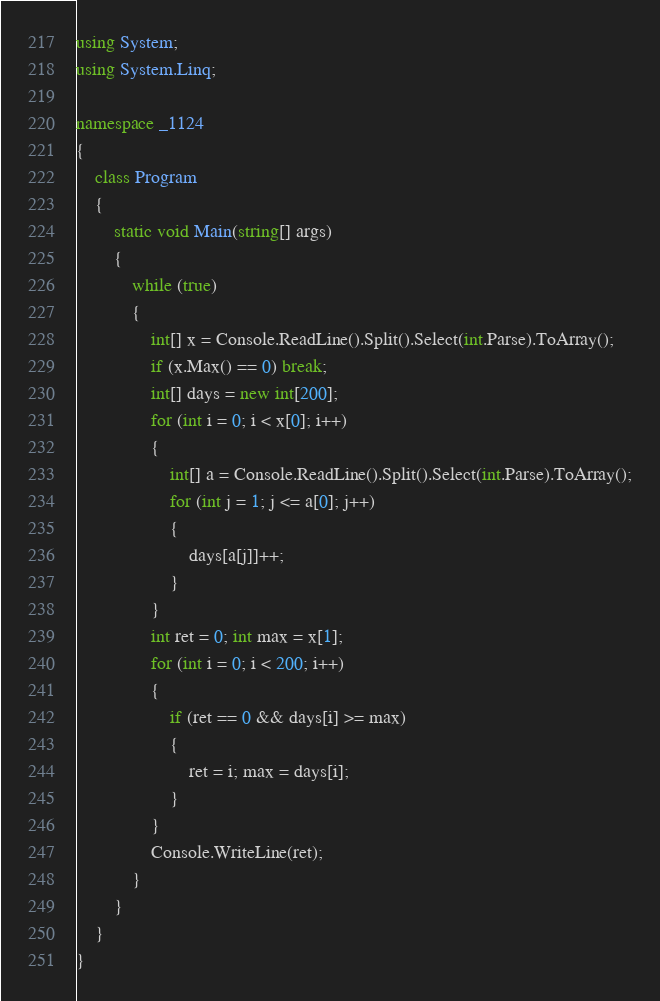Convert code to text. <code><loc_0><loc_0><loc_500><loc_500><_C#_>using System;
using System.Linq;

namespace _1124
{
    class Program
    {
        static void Main(string[] args)
        {
            while (true)
            {
                int[] x = Console.ReadLine().Split().Select(int.Parse).ToArray();
                if (x.Max() == 0) break;
                int[] days = new int[200];
                for (int i = 0; i < x[0]; i++)
                {
                    int[] a = Console.ReadLine().Split().Select(int.Parse).ToArray();
                    for (int j = 1; j <= a[0]; j++)
                    {
                        days[a[j]]++;
                    }
                }
                int ret = 0; int max = x[1];
                for (int i = 0; i < 200; i++)
                {
                    if (ret == 0 && days[i] >= max)
                    {
                        ret = i; max = days[i];
                    }
                }
                Console.WriteLine(ret);
            }
        }
    }
}
</code> 